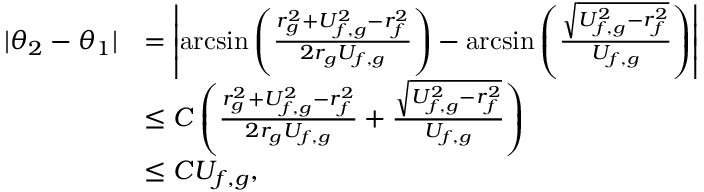Convert formula to latex. <formula><loc_0><loc_0><loc_500><loc_500>\begin{array} { r l } { | \theta _ { 2 } - \theta _ { 1 } | } & { = \left | \arcsin \left ( \frac { r _ { g } ^ { 2 } + U _ { f , g } ^ { 2 } - r _ { f } ^ { 2 } } { 2 r _ { g } U _ { f , g } } \right ) - \arcsin \left ( \frac { \sqrt { U _ { f , g } ^ { 2 } - r _ { f } ^ { 2 } } } { U _ { f , g } } \right ) \right | } \\ & { \leq C \left ( \frac { r _ { g } ^ { 2 } + U _ { f , g } ^ { 2 } - r _ { f } ^ { 2 } } { 2 r _ { g } U _ { f , g } } + \frac { \sqrt { U _ { f , g } ^ { 2 } - r _ { f } ^ { 2 } } } { U _ { f , g } } \right ) } \\ & { \leq C U _ { f , g } , } \end{array}</formula> 